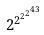<formula> <loc_0><loc_0><loc_500><loc_500>2 ^ { 2 ^ { 2 ^ { 2 ^ { 4 3 } } } }</formula> 